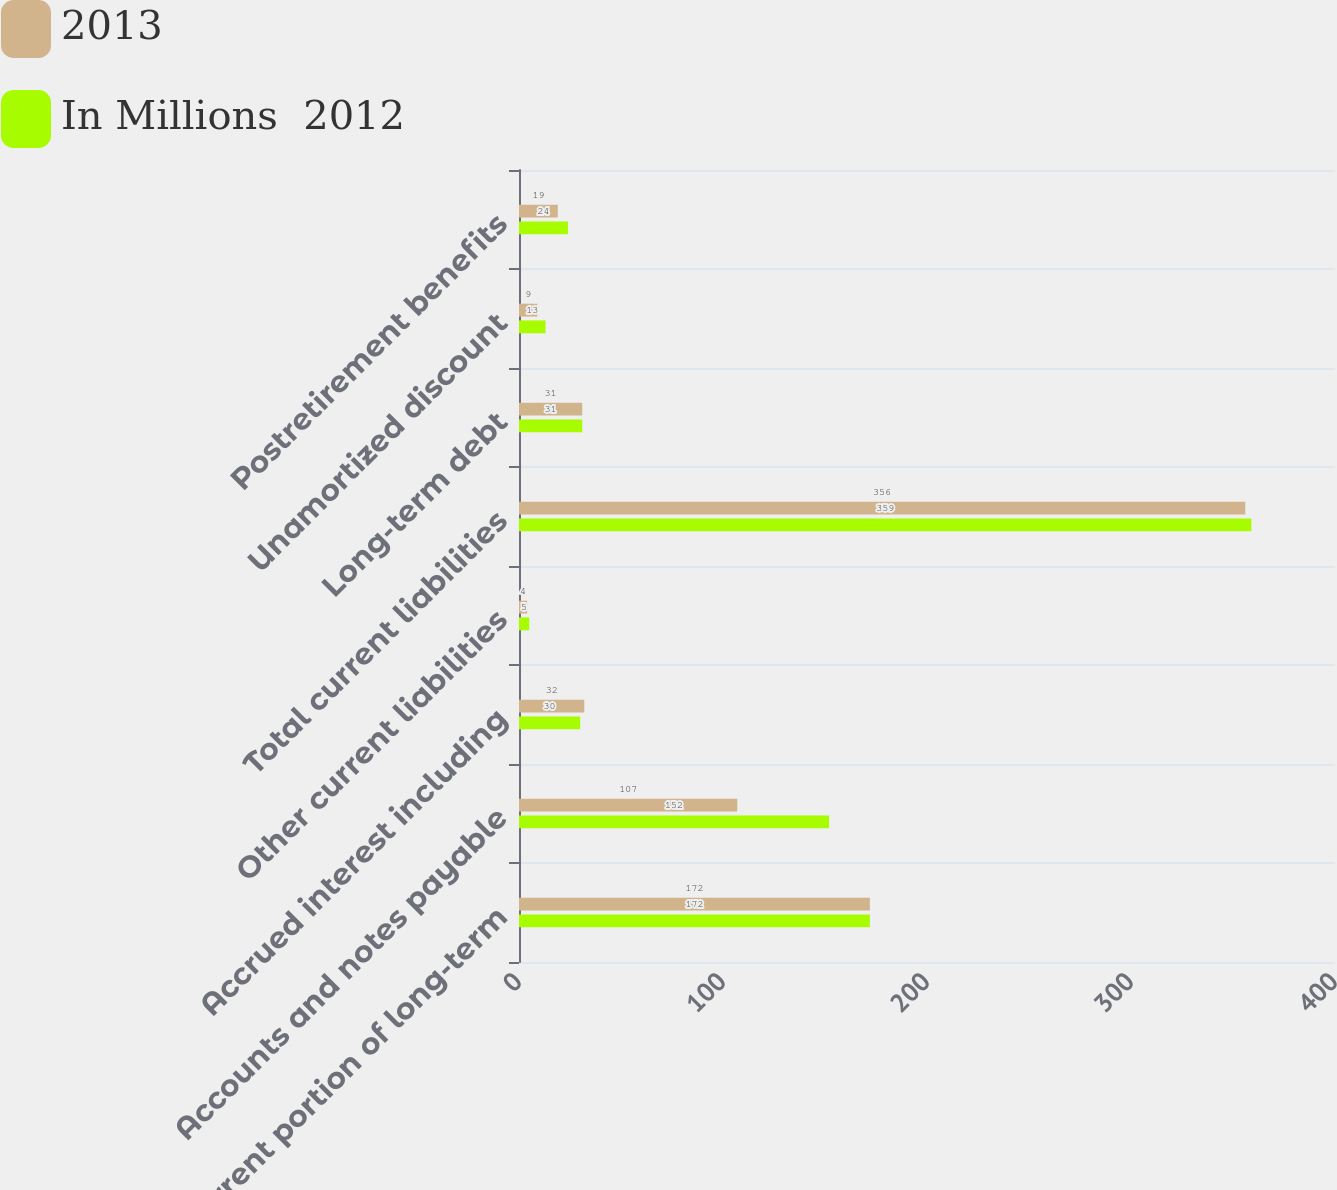<chart> <loc_0><loc_0><loc_500><loc_500><stacked_bar_chart><ecel><fcel>Current portion of long-term<fcel>Accounts and notes payable<fcel>Accrued interest including<fcel>Other current liabilities<fcel>Total current liabilities<fcel>Long-term debt<fcel>Unamortized discount<fcel>Postretirement benefits<nl><fcel>2013<fcel>172<fcel>107<fcel>32<fcel>4<fcel>356<fcel>31<fcel>9<fcel>19<nl><fcel>In Millions  2012<fcel>172<fcel>152<fcel>30<fcel>5<fcel>359<fcel>31<fcel>13<fcel>24<nl></chart> 